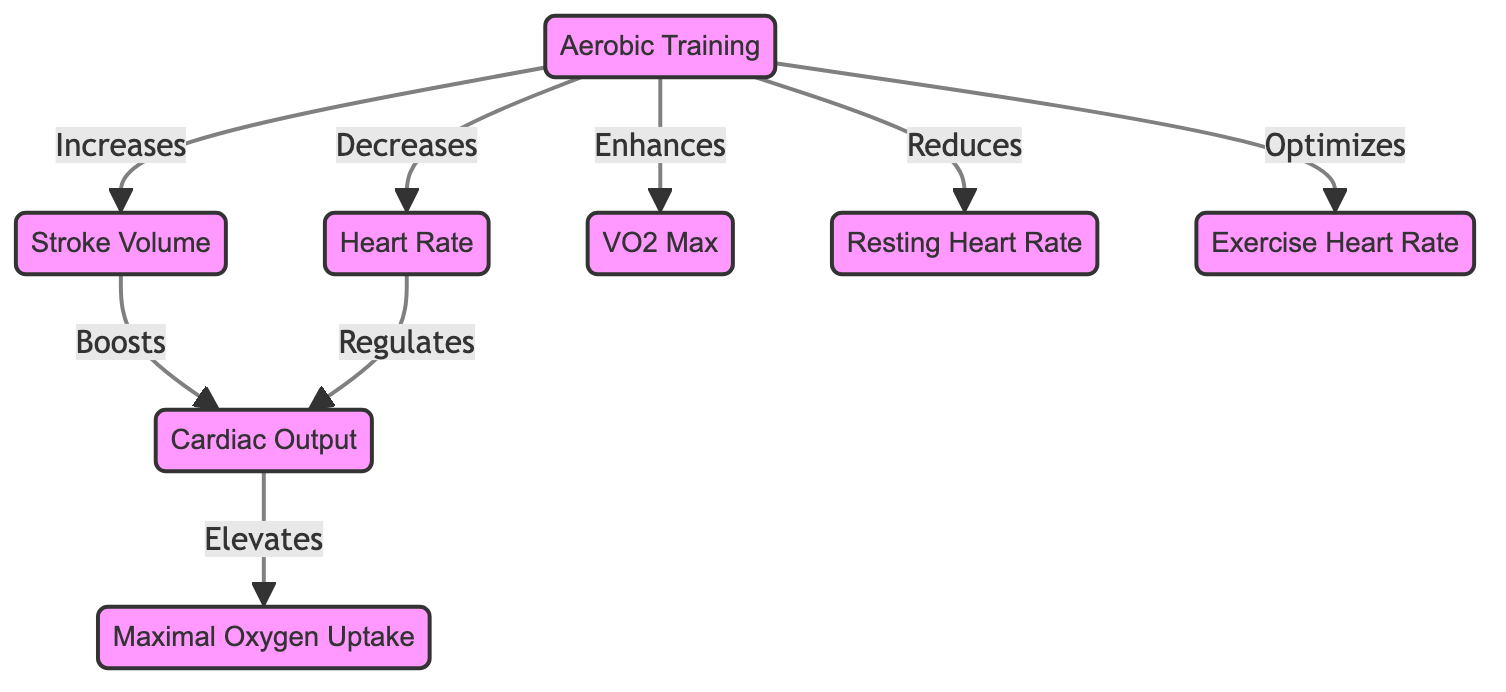What impact does aerobic training have on heart rate? Aerobic training is shown to decrease heart rate in the diagram. This relationship is directly indicated by the arrow between "Aerobic Training" and "Heart Rate" with the label "Decreases."
Answer: Decreases How does stroke volume relate to cardiac output? The diagram illustrates that stroke volume boosts cardiac output through the direct connection labeled "Boosts." This means that an increase in stroke volume directly leads to an increase in cardiac output.
Answer: Boosts What is the effect of aerobic training on resting heart rate? According to the diagram, aerobic training reduces resting heart rate. This is depicted with the arrow from "Aerobic Training" to "Resting Heart Rate" labeled "Reduces."
Answer: Reduces How many nodes are in the diagram? The diagram contains a total of eight nodes representing different aspects of the cardiovascular system and aerobic training. These nodes are: Aerobic Training, Heart Rate, Stroke Volume, VO2 Max, Maximal Oxygen Uptake, Cardiac Output, Resting Heart Rate, and Exercise Heart Rate.
Answer: 8 What relationship does cardiac output have with maximal oxygen uptake? Cardiac output elevates maximal oxygen uptake, as indicated by the arrow from "Cardiac Output" to "Maximal Oxygen Uptake" labeled "Elevates." This illustrates that an increase in cardiac output leads to an increase in maximal oxygen uptake.
Answer: Elevates How does aerobic training impact exercise heart rate? The diagram suggests that aerobic training optimizes exercise heart rate, demonstrated by the connection labeled "Optimizes" leading from "Aerobic Training" to "Exercise Heart Rate."
Answer: Optimizes What type of training primarily leads to changes in VO2 max? The primary type of training that leads to increases in VO2 max is aerobic training, as directly indicated by the arrow from "Aerobic Training" to "VO2 Max" labeled "Enhances."
Answer: Aerobic Training What components are affected by aerobic training according to the diagram? Aerobic training affects heart rate, stroke volume, VO2 max, resting heart rate, and exercise heart rate, as shown by the multiple connections (decreases, increases, enhances, reduces, optimizes) stemming from the "Aerobic Training" node.
Answer: Heart Rate, Stroke Volume, VO2 Max, Resting Heart Rate, Exercise Heart Rate 